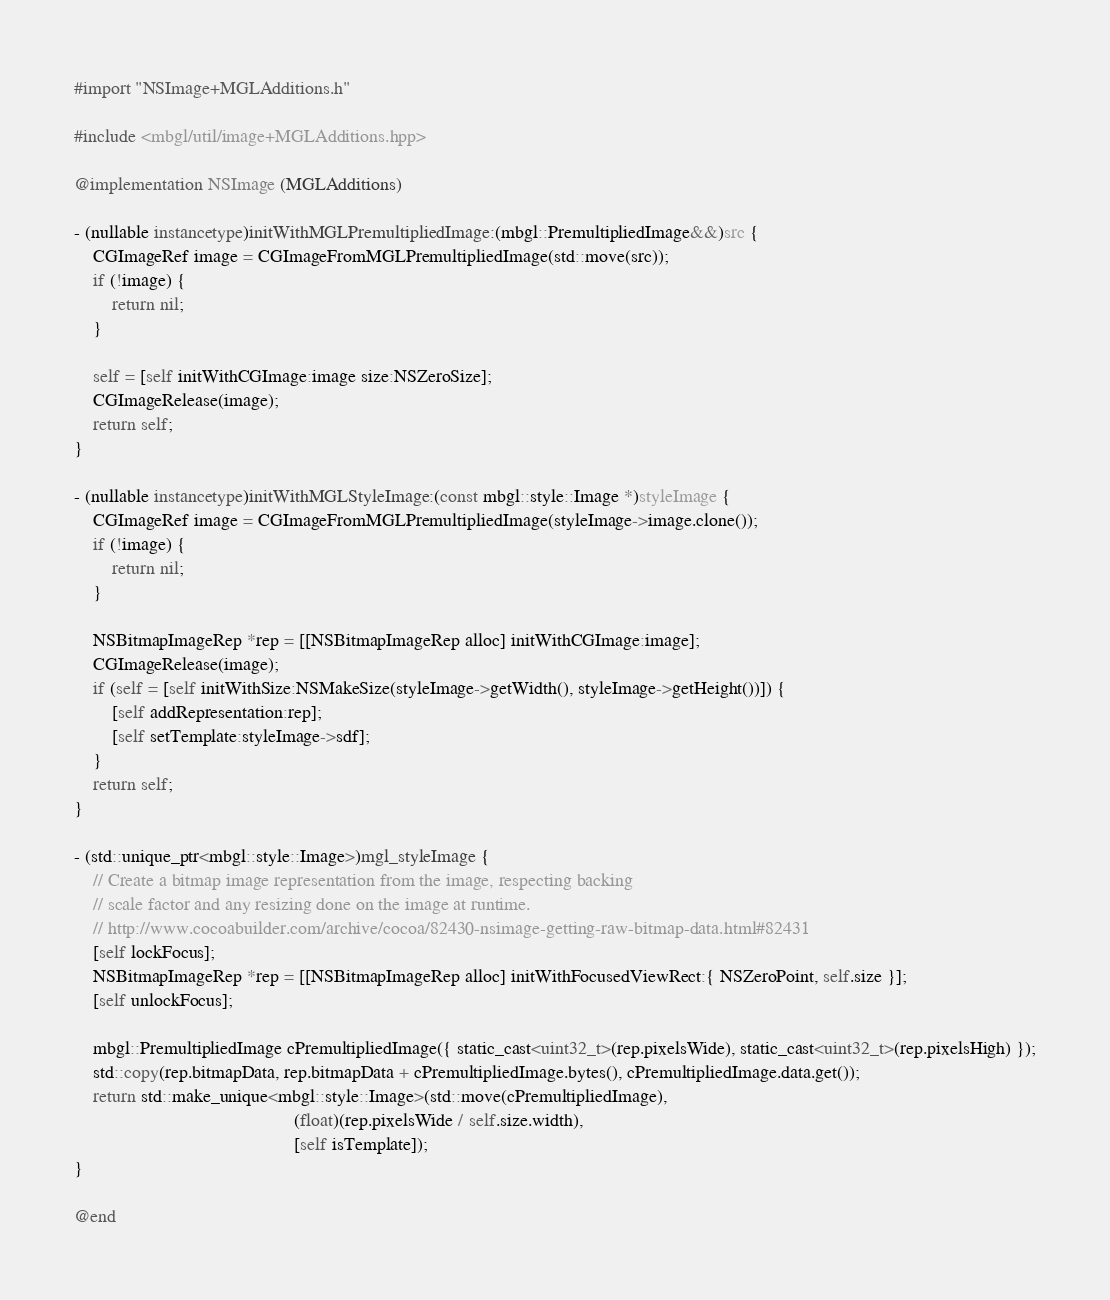Convert code to text. <code><loc_0><loc_0><loc_500><loc_500><_ObjectiveC_>#import "NSImage+MGLAdditions.h"

#include <mbgl/util/image+MGLAdditions.hpp>

@implementation NSImage (MGLAdditions)

- (nullable instancetype)initWithMGLPremultipliedImage:(mbgl::PremultipliedImage&&)src {
    CGImageRef image = CGImageFromMGLPremultipliedImage(std::move(src));
    if (!image) {
        return nil;
    }

    self = [self initWithCGImage:image size:NSZeroSize];
    CGImageRelease(image);
    return self;
}

- (nullable instancetype)initWithMGLStyleImage:(const mbgl::style::Image *)styleImage {
    CGImageRef image = CGImageFromMGLPremultipliedImage(styleImage->image.clone());
    if (!image) {
        return nil;
    }

    NSBitmapImageRep *rep = [[NSBitmapImageRep alloc] initWithCGImage:image];
    CGImageRelease(image);
    if (self = [self initWithSize:NSMakeSize(styleImage->getWidth(), styleImage->getHeight())]) {
        [self addRepresentation:rep];
        [self setTemplate:styleImage->sdf];
    }
    return self;
}

- (std::unique_ptr<mbgl::style::Image>)mgl_styleImage {
    // Create a bitmap image representation from the image, respecting backing
    // scale factor and any resizing done on the image at runtime.
    // http://www.cocoabuilder.com/archive/cocoa/82430-nsimage-getting-raw-bitmap-data.html#82431
    [self lockFocus];
    NSBitmapImageRep *rep = [[NSBitmapImageRep alloc] initWithFocusedViewRect:{ NSZeroPoint, self.size }];
    [self unlockFocus];

    mbgl::PremultipliedImage cPremultipliedImage({ static_cast<uint32_t>(rep.pixelsWide), static_cast<uint32_t>(rep.pixelsHigh) });
    std::copy(rep.bitmapData, rep.bitmapData + cPremultipliedImage.bytes(), cPremultipliedImage.data.get());
    return std::make_unique<mbgl::style::Image>(std::move(cPremultipliedImage),
                                               (float)(rep.pixelsWide / self.size.width),
                                               [self isTemplate]);
}

@end
</code> 